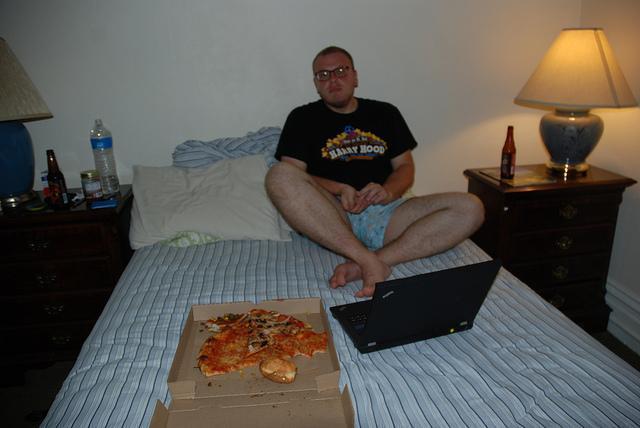How many laptops are pictured?
Give a very brief answer. 1. 